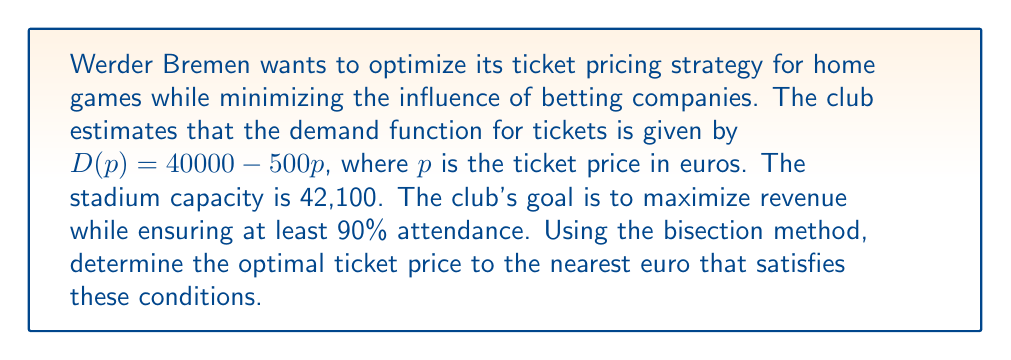Help me with this question. Let's approach this step-by-step:

1) The revenue function $R(p)$ is given by price times demand:
   $R(p) = p \cdot D(p) = p(40000 - 500p) = 40000p - 500p^2$

2) We need to ensure at least 90% attendance:
   $0.9 \cdot 42100 = 37890$ seats

3) So, our constraint is:
   $40000 - 500p \geq 37890$
   $2110 \geq 500p$
   $p \leq 4.22$

4) Let's define our function $f(p)$ as the derivative of $R(p)$:
   $f(p) = R'(p) = 40000 - 1000p$

5) We'll use the bisection method on $f(p)$ in the interval $[0, 4.22]$:

   Initial interval: $[a, b] = [0, 4.22]$
   
   Iteration 1:
   $m = (0 + 4.22) / 2 = 2.11$
   $f(2.11) = 40000 - 1000(2.11) = 37890 > 0$
   New interval: $[2.11, 4.22]$

   Iteration 2:
   $m = (2.11 + 4.22) / 2 = 3.165$
   $f(3.165) = 40000 - 1000(3.165) = 36835 > 0$
   New interval: $[3.165, 4.22]$

   Iteration 3:
   $m = (3.165 + 4.22) / 2 = 3.6925$
   $f(3.6925) = 40000 - 1000(3.6925) = 36307.5 > 0$
   New interval: $[3.6925, 4.22]$

   Iteration 4:
   $m = (3.6925 + 4.22) / 2 = 3.95625$
   $f(3.95625) = 40000 - 1000(3.95625) = 36043.75 > 0$
   New interval: $[3.95625, 4.22]$

   Iteration 5:
   $m = (3.95625 + 4.22) / 2 = 4.088125$
   $f(4.088125) = 40000 - 1000(4.088125) = 35911.875 < 0$
   New interval: $[3.95625, 4.088125]$

6) After 5 iterations, we have narrowed down the optimal price to between €3.96 and €4.09.

7) Rounding to the nearest euro gives us €4.
Answer: €4 